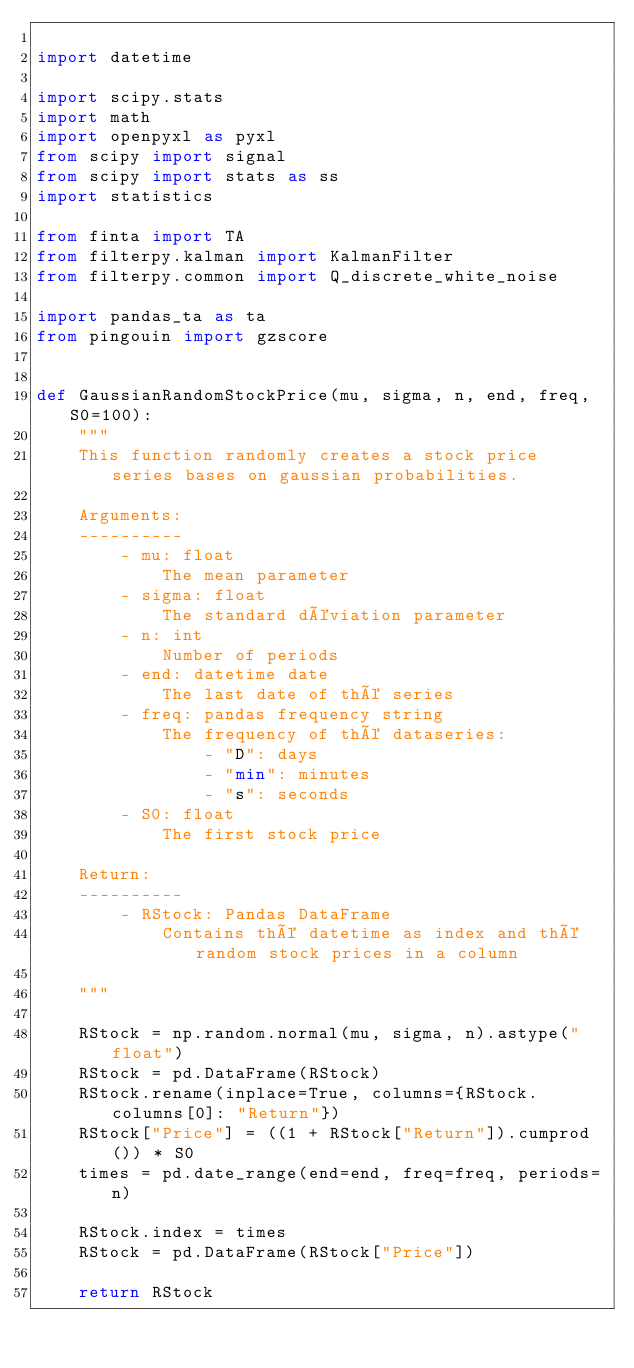Convert code to text. <code><loc_0><loc_0><loc_500><loc_500><_Python_>
import datetime

import scipy.stats
import math
import openpyxl as pyxl
from scipy import signal
from scipy import stats as ss
import statistics

from finta import TA
from filterpy.kalman import KalmanFilter
from filterpy.common import Q_discrete_white_noise

import pandas_ta as ta
from pingouin import gzscore


def GaussianRandomStockPrice(mu, sigma, n, end, freq, S0=100):
    """
    This function randomly creates a stock price series bases on gaussian probabilities.

    Arguments:
    ----------
        - mu: float
            The mean parameter
        - sigma: float
            The standard déviation parameter
        - n: int
            Number of periods
        - end: datetime date
            The last date of thé series
        - freq: pandas frequency string
            The frequency of thé dataseries:
                - "D": days
                - "min": minutes
                - "s": seconds
        - S0: float
            The first stock price

    Return:
    ----------
        - RStock: Pandas DataFrame
            Contains thé datetime as index and thé random stock prices in a column

    """

    RStock = np.random.normal(mu, sigma, n).astype("float")
    RStock = pd.DataFrame(RStock)
    RStock.rename(inplace=True, columns={RStock.columns[0]: "Return"})
    RStock["Price"] = ((1 + RStock["Return"]).cumprod()) * S0
    times = pd.date_range(end=end, freq=freq, periods=n)

    RStock.index = times
    RStock = pd.DataFrame(RStock["Price"])

    return RStock
</code> 